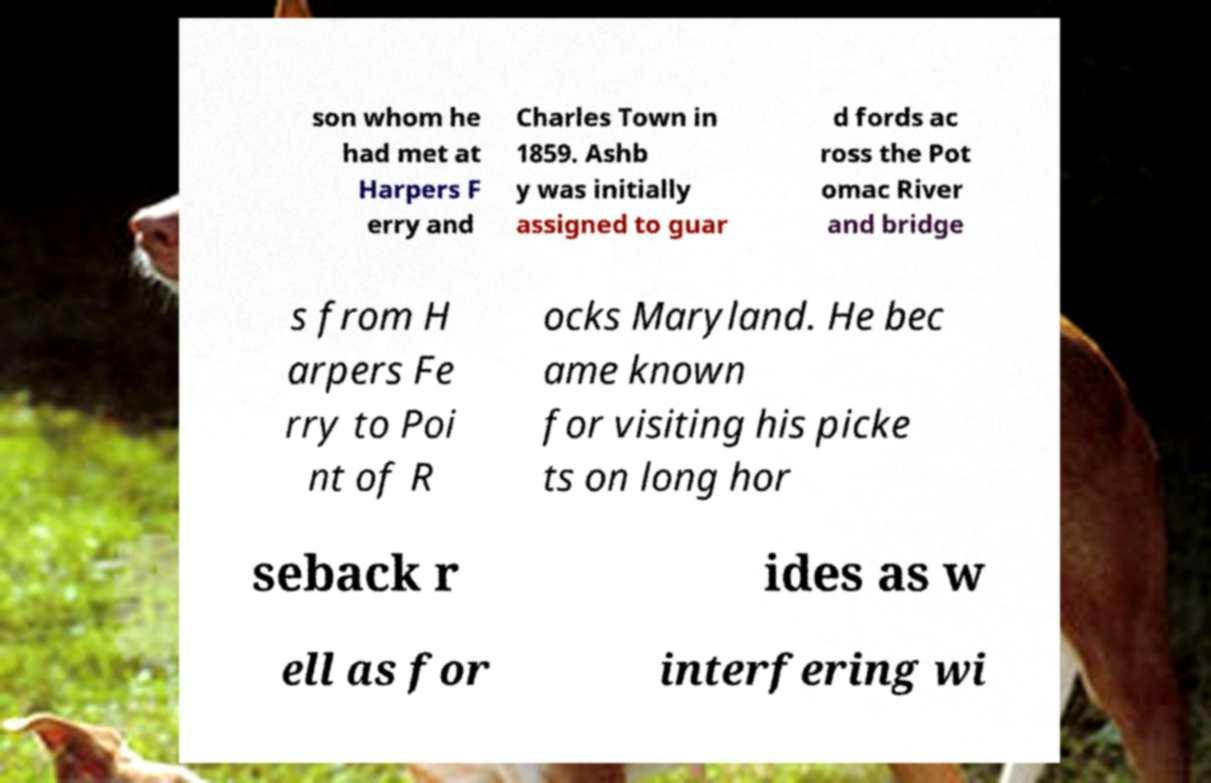Can you accurately transcribe the text from the provided image for me? son whom he had met at Harpers F erry and Charles Town in 1859. Ashb y was initially assigned to guar d fords ac ross the Pot omac River and bridge s from H arpers Fe rry to Poi nt of R ocks Maryland. He bec ame known for visiting his picke ts on long hor seback r ides as w ell as for interfering wi 